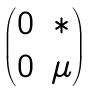Convert formula to latex. <formula><loc_0><loc_0><loc_500><loc_500>\begin{pmatrix} 0 & * \\ 0 & \mu \end{pmatrix}</formula> 